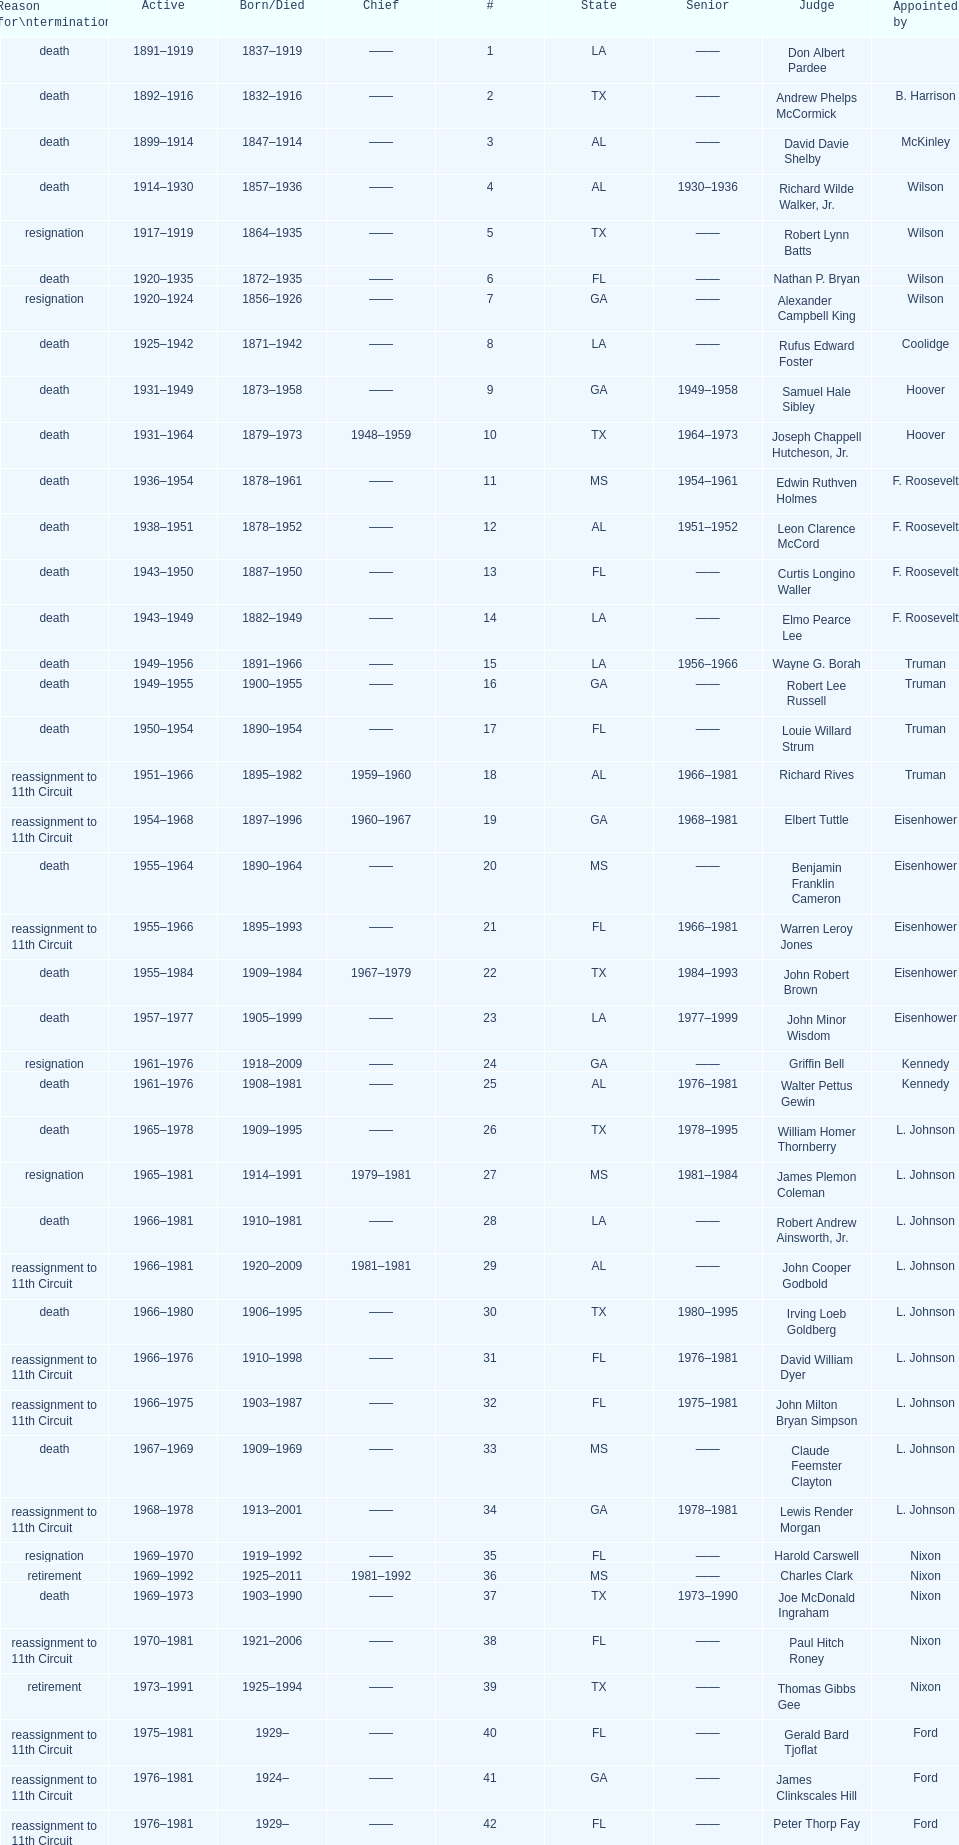Can you parse all the data within this table? {'header': ['Reason for\\ntermination', 'Active', 'Born/Died', 'Chief', '#', 'State', 'Senior', 'Judge', 'Appointed by'], 'rows': [['death', '1891–1919', '1837–1919', '——', '1', 'LA', '——', 'Don Albert Pardee', ''], ['death', '1892–1916', '1832–1916', '——', '2', 'TX', '——', 'Andrew Phelps McCormick', 'B. Harrison'], ['death', '1899–1914', '1847–1914', '——', '3', 'AL', '——', 'David Davie Shelby', 'McKinley'], ['death', '1914–1930', '1857–1936', '——', '4', 'AL', '1930–1936', 'Richard Wilde Walker, Jr.', 'Wilson'], ['resignation', '1917–1919', '1864–1935', '——', '5', 'TX', '——', 'Robert Lynn Batts', 'Wilson'], ['death', '1920–1935', '1872–1935', '——', '6', 'FL', '——', 'Nathan P. Bryan', 'Wilson'], ['resignation', '1920–1924', '1856–1926', '——', '7', 'GA', '——', 'Alexander Campbell King', 'Wilson'], ['death', '1925–1942', '1871–1942', '——', '8', 'LA', '——', 'Rufus Edward Foster', 'Coolidge'], ['death', '1931–1949', '1873–1958', '——', '9', 'GA', '1949–1958', 'Samuel Hale Sibley', 'Hoover'], ['death', '1931–1964', '1879–1973', '1948–1959', '10', 'TX', '1964–1973', 'Joseph Chappell Hutcheson, Jr.', 'Hoover'], ['death', '1936–1954', '1878–1961', '——', '11', 'MS', '1954–1961', 'Edwin Ruthven Holmes', 'F. Roosevelt'], ['death', '1938–1951', '1878–1952', '——', '12', 'AL', '1951–1952', 'Leon Clarence McCord', 'F. Roosevelt'], ['death', '1943–1950', '1887–1950', '——', '13', 'FL', '——', 'Curtis Longino Waller', 'F. Roosevelt'], ['death', '1943–1949', '1882–1949', '——', '14', 'LA', '——', 'Elmo Pearce Lee', 'F. Roosevelt'], ['death', '1949–1956', '1891–1966', '——', '15', 'LA', '1956–1966', 'Wayne G. Borah', 'Truman'], ['death', '1949–1955', '1900–1955', '——', '16', 'GA', '——', 'Robert Lee Russell', 'Truman'], ['death', '1950–1954', '1890–1954', '——', '17', 'FL', '——', 'Louie Willard Strum', 'Truman'], ['reassignment to 11th Circuit', '1951–1966', '1895–1982', '1959–1960', '18', 'AL', '1966–1981', 'Richard Rives', 'Truman'], ['reassignment to 11th Circuit', '1954–1968', '1897–1996', '1960–1967', '19', 'GA', '1968–1981', 'Elbert Tuttle', 'Eisenhower'], ['death', '1955–1964', '1890–1964', '——', '20', 'MS', '——', 'Benjamin Franklin Cameron', 'Eisenhower'], ['reassignment to 11th Circuit', '1955–1966', '1895–1993', '——', '21', 'FL', '1966–1981', 'Warren Leroy Jones', 'Eisenhower'], ['death', '1955–1984', '1909–1984', '1967–1979', '22', 'TX', '1984–1993', 'John Robert Brown', 'Eisenhower'], ['death', '1957–1977', '1905–1999', '——', '23', 'LA', '1977–1999', 'John Minor Wisdom', 'Eisenhower'], ['resignation', '1961–1976', '1918–2009', '——', '24', 'GA', '——', 'Griffin Bell', 'Kennedy'], ['death', '1961–1976', '1908–1981', '——', '25', 'AL', '1976–1981', 'Walter Pettus Gewin', 'Kennedy'], ['death', '1965–1978', '1909–1995', '——', '26', 'TX', '1978–1995', 'William Homer Thornberry', 'L. Johnson'], ['resignation', '1965–1981', '1914–1991', '1979–1981', '27', 'MS', '1981–1984', 'James Plemon Coleman', 'L. Johnson'], ['death', '1966–1981', '1910–1981', '——', '28', 'LA', '——', 'Robert Andrew Ainsworth, Jr.', 'L. Johnson'], ['reassignment to 11th Circuit', '1966–1981', '1920–2009', '1981–1981', '29', 'AL', '——', 'John Cooper Godbold', 'L. Johnson'], ['death', '1966–1980', '1906–1995', '——', '30', 'TX', '1980–1995', 'Irving Loeb Goldberg', 'L. Johnson'], ['reassignment to 11th Circuit', '1966–1976', '1910–1998', '——', '31', 'FL', '1976–1981', 'David William Dyer', 'L. Johnson'], ['reassignment to 11th Circuit', '1966–1975', '1903–1987', '——', '32', 'FL', '1975–1981', 'John Milton Bryan Simpson', 'L. Johnson'], ['death', '1967–1969', '1909–1969', '——', '33', 'MS', '——', 'Claude Feemster Clayton', 'L. Johnson'], ['reassignment to 11th Circuit', '1968–1978', '1913–2001', '——', '34', 'GA', '1978–1981', 'Lewis Render Morgan', 'L. Johnson'], ['resignation', '1969–1970', '1919–1992', '——', '35', 'FL', '——', 'Harold Carswell', 'Nixon'], ['retirement', '1969–1992', '1925–2011', '1981–1992', '36', 'MS', '——', 'Charles Clark', 'Nixon'], ['death', '1969–1973', '1903–1990', '——', '37', 'TX', '1973–1990', 'Joe McDonald Ingraham', 'Nixon'], ['reassignment to 11th Circuit', '1970–1981', '1921–2006', '——', '38', 'FL', '——', 'Paul Hitch Roney', 'Nixon'], ['retirement', '1973–1991', '1925–1994', '——', '39', 'TX', '——', 'Thomas Gibbs Gee', 'Nixon'], ['reassignment to 11th Circuit', '1975–1981', '1929–', '——', '40', 'FL', '——', 'Gerald Bard Tjoflat', 'Ford'], ['reassignment to 11th Circuit', '1976–1981', '1924–', '——', '41', 'GA', '——', 'James Clinkscales Hill', 'Ford'], ['reassignment to 11th Circuit', '1976–1981', '1929–', '——', '42', 'FL', '——', 'Peter Thorp Fay', 'Ford'], ['death', '1977–1989', '1920–1991', '——', '43', 'LA', '1989–1991', 'Alvin Benjamin Rubin', 'Carter'], ['reassignment to 11th Circuit', '1977–1981', '1931–1989', '——', '44', 'AL', '——', 'Robert Smith Vance', 'Carter'], ['reassignment to 11th Circuit', '1979–1981', '1920–', '——', '45', 'GA', '——', 'Phyllis A. Kravitch', 'Carter'], ['reassignment to 11th Circuit', '1979–1981', '1918–1999', '——', '46', 'AL', '——', 'Frank Minis Johnson', 'Carter'], ['reassignment to 11th Circuit', '1979–1981', '1936–', '——', '47', 'GA', '——', 'R. Lanier Anderson III', 'Carter'], ['death', '1979–1982', '1915–2004', '——', '48', 'TX', '1982–2004', 'Reynaldo Guerra Garza', 'Carter'], ['reassignment to 11th Circuit', '1979–1981', '1932–', '——', '49', 'FL', '——', 'Joseph Woodrow Hatchett', 'Carter'], ['reassignment to 11th Circuit', '1979–1981', '1920–1999', '——', '50', 'GA', '——', 'Albert John Henderson', 'Carter'], ['death', '1979–1999', '1932–2002', '1992–1999', '52', 'LA', '1999–2002', 'Henry Anthony Politz', 'Carter'], ['death', '1979–1991', '1920–2002', '——', '54', 'TX', '1991–2002', 'Samuel D. Johnson, Jr.', 'Carter'], ['death', '1979–1986', '1920–1986', '——', '55', 'LA', '——', 'Albert Tate, Jr.', 'Carter'], ['reassignment to 11th Circuit', '1979–1981', '1920–2005', '——', '56', 'GA', '——', 'Thomas Alonzo Clark', 'Carter'], ['death', '1980–1990', '1916–1993', '——', '57', 'TX', '1990–1993', 'Jerre Stockton Williams', 'Carter'], ['death', '1981–1997', '1931–2011', '——', '58', 'TX', '1997–2011', 'William Lockhart Garwood', 'Reagan'], ['death', '1984–1987', '1928–1987', '——', '62', 'TX', '——', 'Robert Madden Hill', 'Reagan'], ['retirement', '1988–1999', '1933-', '——', '65', 'LA', '1999–2011', 'John Malcolm Duhé, Jr.', 'Reagan'], ['retirement', '1994–2002', '1937–', '——', '72', 'TX', '——', 'Robert Manley Parker', 'Clinton'], ['retirement', '2004–2004', '1937–', '——', '76', 'MS', '——', 'Charles W. Pickering', 'G.W. Bush']]} Who was the next judge to resign after alexander campbell king? Griffin Bell. 